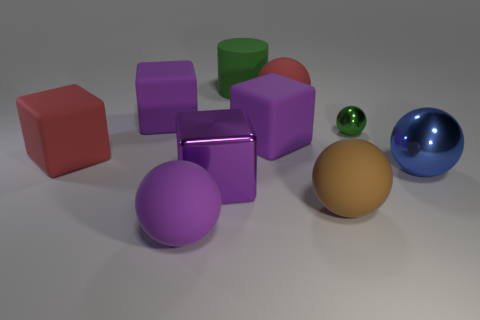Subtract all green cylinders. How many purple blocks are left? 3 Subtract all blue spheres. How many spheres are left? 4 Subtract all big red rubber balls. How many balls are left? 4 Subtract all cyan spheres. Subtract all red cylinders. How many spheres are left? 5 Subtract all cylinders. How many objects are left? 9 Subtract 1 purple spheres. How many objects are left? 9 Subtract all purple rubber balls. Subtract all matte blocks. How many objects are left? 6 Add 1 large blue shiny objects. How many large blue shiny objects are left? 2 Add 10 small brown rubber things. How many small brown rubber things exist? 10 